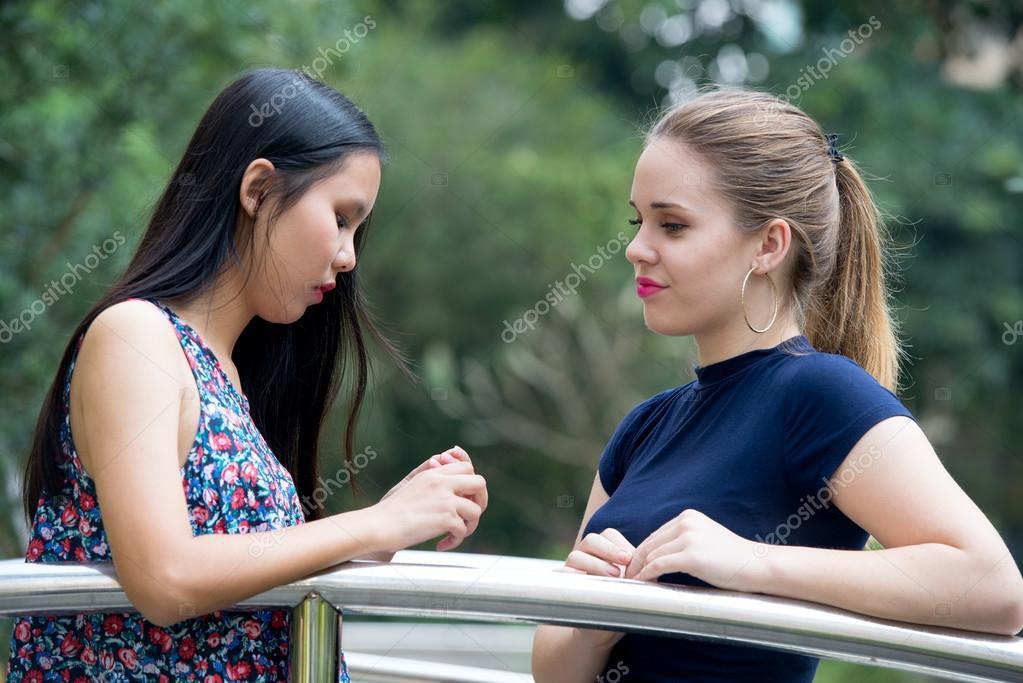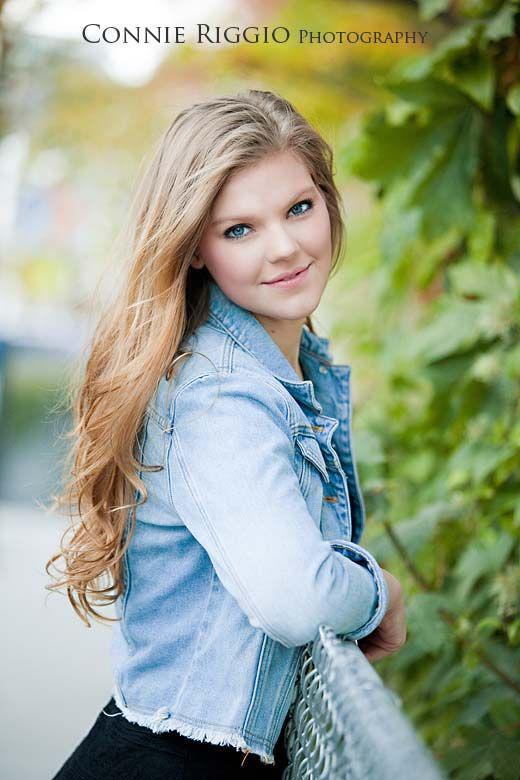The first image is the image on the left, the second image is the image on the right. For the images shown, is this caption "One image shows exactly one girl standing and leaning with her arms on a rail, and smiling at the camera." true? Answer yes or no. Yes. 